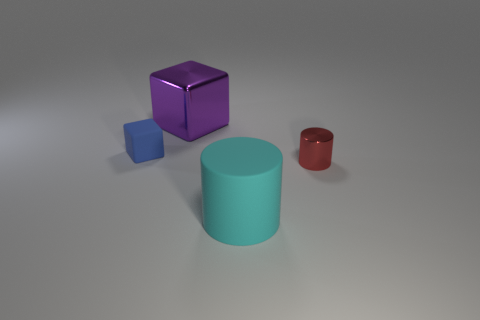Add 2 tiny green balls. How many objects exist? 6 Add 1 tiny red metallic objects. How many tiny red metallic objects are left? 2 Add 2 big cyan blocks. How many big cyan blocks exist? 2 Subtract 0 gray cylinders. How many objects are left? 4 Subtract all large metallic things. Subtract all blue matte balls. How many objects are left? 3 